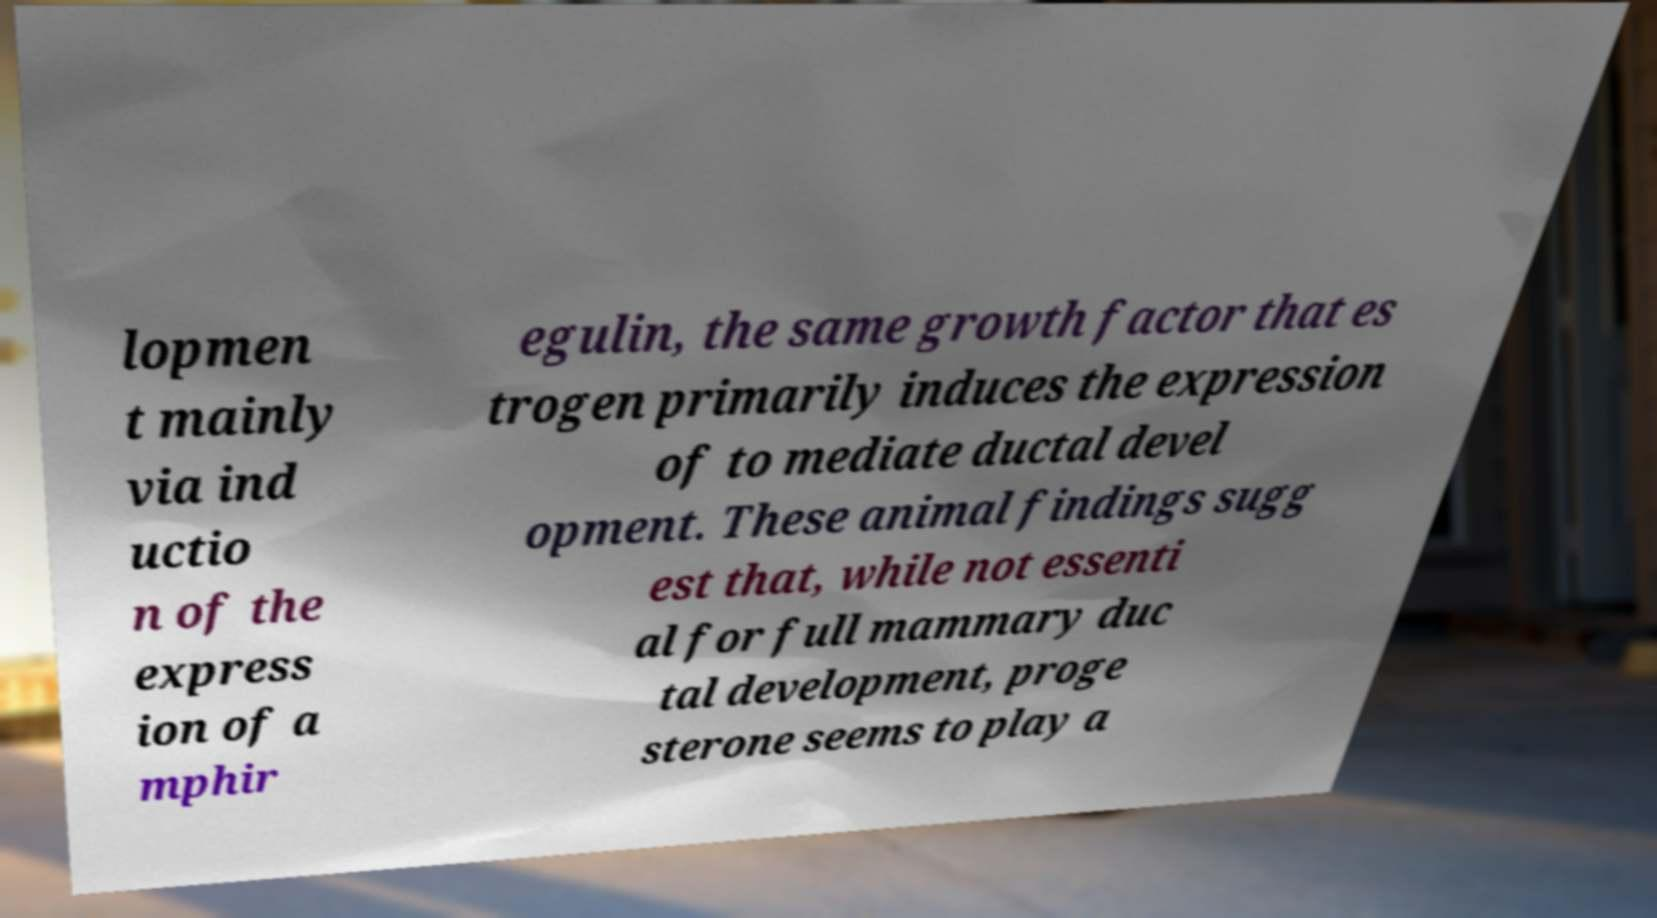Could you assist in decoding the text presented in this image and type it out clearly? lopmen t mainly via ind uctio n of the express ion of a mphir egulin, the same growth factor that es trogen primarily induces the expression of to mediate ductal devel opment. These animal findings sugg est that, while not essenti al for full mammary duc tal development, proge sterone seems to play a 